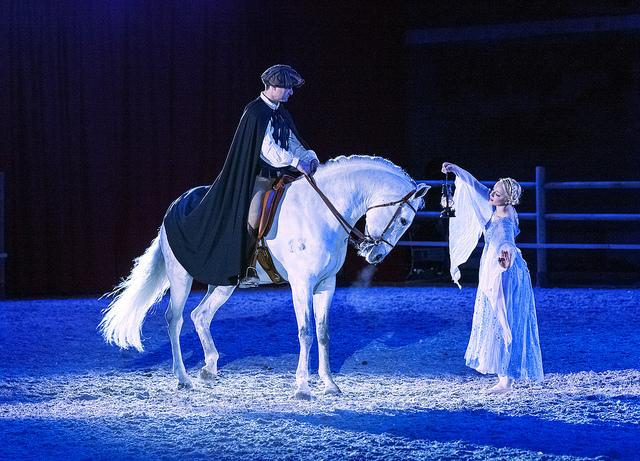Does this scene depict reality?
Concise answer only. No. What does the dress wearer carry?
Answer briefly. Lantern. Is anybody wearing a harness?
Keep it brief. Yes. 